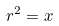<formula> <loc_0><loc_0><loc_500><loc_500>r ^ { 2 } = x \,</formula> 